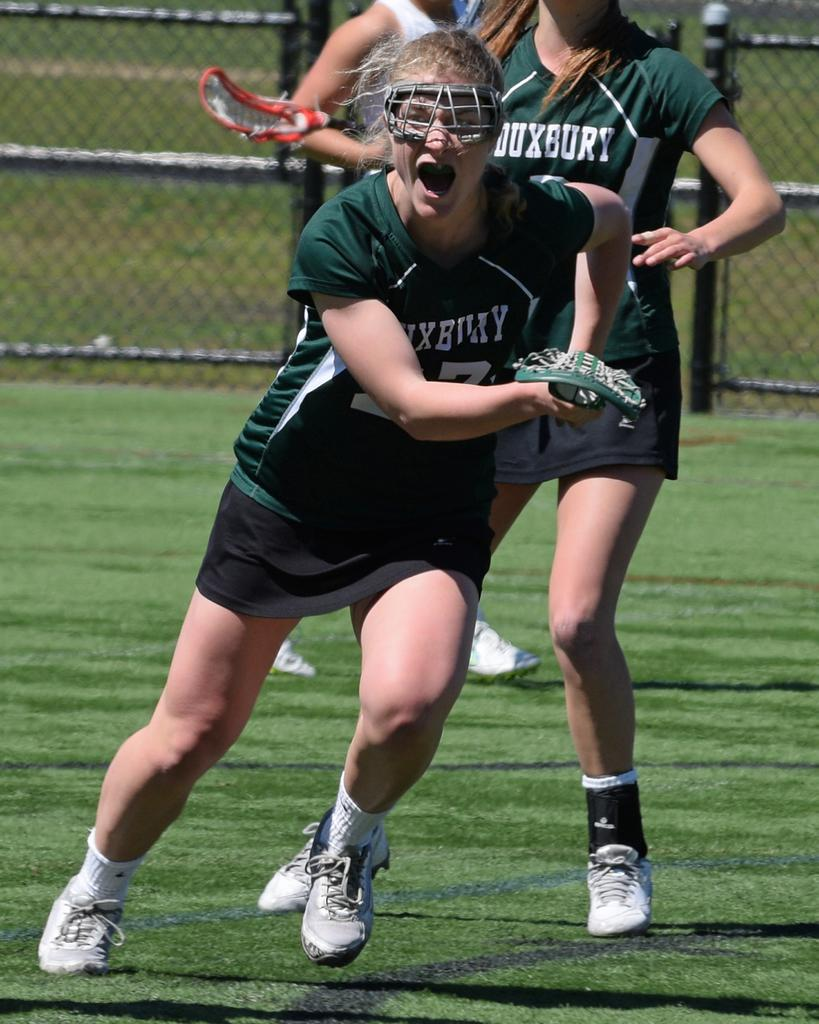What is happening in the image? There are persons standing in the image. What is the color of the ground in the image? The ground is green in the image. What can be seen in the background of the image? There is a fence in the background of the image. How many nails are visible in the image? There are no nails present in the image. What type of bird's nest can be seen in the image? There is no bird's nest present in the image. 